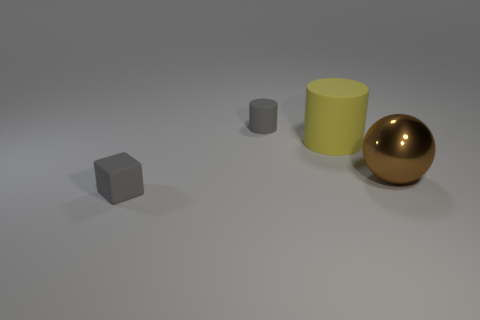How do the textures of the objects compare to each other? The yellow cylinder and the gray cube and cylinder exhibit a matte texture, while the gold sphere has a reflective, shiny surface. 